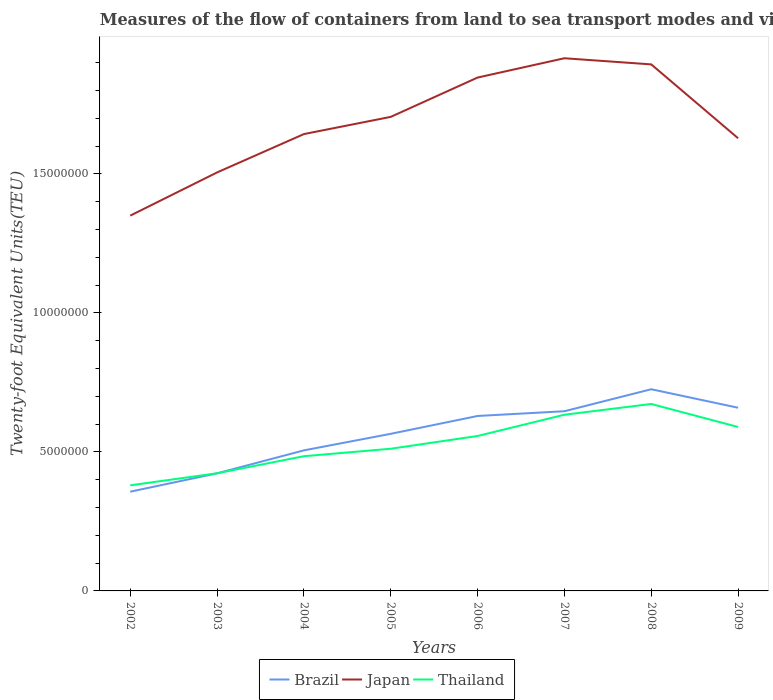How many different coloured lines are there?
Provide a succinct answer. 3. Across all years, what is the maximum container port traffic in Japan?
Make the answer very short. 1.35e+07. In which year was the container port traffic in Japan maximum?
Give a very brief answer. 2002. What is the total container port traffic in Thailand in the graph?
Your response must be concise. -1.34e+06. What is the difference between the highest and the second highest container port traffic in Thailand?
Ensure brevity in your answer.  2.93e+06. What is the difference between the highest and the lowest container port traffic in Japan?
Provide a short and direct response. 4. Is the container port traffic in Japan strictly greater than the container port traffic in Brazil over the years?
Make the answer very short. No. Are the values on the major ticks of Y-axis written in scientific E-notation?
Offer a very short reply. No. Does the graph contain grids?
Your answer should be very brief. No. How are the legend labels stacked?
Offer a terse response. Horizontal. What is the title of the graph?
Your response must be concise. Measures of the flow of containers from land to sea transport modes and vice versa. What is the label or title of the X-axis?
Ensure brevity in your answer.  Years. What is the label or title of the Y-axis?
Keep it short and to the point. Twenty-foot Equivalent Units(TEU). What is the Twenty-foot Equivalent Units(TEU) of Brazil in 2002?
Give a very brief answer. 3.57e+06. What is the Twenty-foot Equivalent Units(TEU) of Japan in 2002?
Your answer should be very brief. 1.35e+07. What is the Twenty-foot Equivalent Units(TEU) in Thailand in 2002?
Keep it short and to the point. 3.80e+06. What is the Twenty-foot Equivalent Units(TEU) in Brazil in 2003?
Your response must be concise. 4.23e+06. What is the Twenty-foot Equivalent Units(TEU) of Japan in 2003?
Provide a succinct answer. 1.51e+07. What is the Twenty-foot Equivalent Units(TEU) of Thailand in 2003?
Your response must be concise. 4.23e+06. What is the Twenty-foot Equivalent Units(TEU) of Brazil in 2004?
Give a very brief answer. 5.06e+06. What is the Twenty-foot Equivalent Units(TEU) in Japan in 2004?
Your answer should be compact. 1.64e+07. What is the Twenty-foot Equivalent Units(TEU) in Thailand in 2004?
Make the answer very short. 4.85e+06. What is the Twenty-foot Equivalent Units(TEU) of Brazil in 2005?
Provide a succinct answer. 5.65e+06. What is the Twenty-foot Equivalent Units(TEU) of Japan in 2005?
Make the answer very short. 1.71e+07. What is the Twenty-foot Equivalent Units(TEU) in Thailand in 2005?
Keep it short and to the point. 5.12e+06. What is the Twenty-foot Equivalent Units(TEU) in Brazil in 2006?
Your answer should be very brief. 6.29e+06. What is the Twenty-foot Equivalent Units(TEU) of Japan in 2006?
Your answer should be compact. 1.85e+07. What is the Twenty-foot Equivalent Units(TEU) in Thailand in 2006?
Your answer should be compact. 5.57e+06. What is the Twenty-foot Equivalent Units(TEU) of Brazil in 2007?
Your answer should be very brief. 6.46e+06. What is the Twenty-foot Equivalent Units(TEU) in Japan in 2007?
Offer a very short reply. 1.92e+07. What is the Twenty-foot Equivalent Units(TEU) in Thailand in 2007?
Provide a succinct answer. 6.34e+06. What is the Twenty-foot Equivalent Units(TEU) of Brazil in 2008?
Offer a terse response. 7.26e+06. What is the Twenty-foot Equivalent Units(TEU) of Japan in 2008?
Provide a short and direct response. 1.89e+07. What is the Twenty-foot Equivalent Units(TEU) of Thailand in 2008?
Your answer should be very brief. 6.73e+06. What is the Twenty-foot Equivalent Units(TEU) of Brazil in 2009?
Keep it short and to the point. 6.59e+06. What is the Twenty-foot Equivalent Units(TEU) of Japan in 2009?
Give a very brief answer. 1.63e+07. What is the Twenty-foot Equivalent Units(TEU) of Thailand in 2009?
Ensure brevity in your answer.  5.90e+06. Across all years, what is the maximum Twenty-foot Equivalent Units(TEU) in Brazil?
Your response must be concise. 7.26e+06. Across all years, what is the maximum Twenty-foot Equivalent Units(TEU) of Japan?
Provide a succinct answer. 1.92e+07. Across all years, what is the maximum Twenty-foot Equivalent Units(TEU) of Thailand?
Give a very brief answer. 6.73e+06. Across all years, what is the minimum Twenty-foot Equivalent Units(TEU) in Brazil?
Your answer should be very brief. 3.57e+06. Across all years, what is the minimum Twenty-foot Equivalent Units(TEU) of Japan?
Make the answer very short. 1.35e+07. Across all years, what is the minimum Twenty-foot Equivalent Units(TEU) in Thailand?
Your answer should be very brief. 3.80e+06. What is the total Twenty-foot Equivalent Units(TEU) in Brazil in the graph?
Provide a short and direct response. 4.51e+07. What is the total Twenty-foot Equivalent Units(TEU) of Japan in the graph?
Keep it short and to the point. 1.35e+08. What is the total Twenty-foot Equivalent Units(TEU) in Thailand in the graph?
Ensure brevity in your answer.  4.25e+07. What is the difference between the Twenty-foot Equivalent Units(TEU) in Brazil in 2002 and that in 2003?
Provide a short and direct response. -6.60e+05. What is the difference between the Twenty-foot Equivalent Units(TEU) of Japan in 2002 and that in 2003?
Your answer should be very brief. -1.55e+06. What is the difference between the Twenty-foot Equivalent Units(TEU) in Thailand in 2002 and that in 2003?
Offer a terse response. -4.34e+05. What is the difference between the Twenty-foot Equivalent Units(TEU) of Brazil in 2002 and that in 2004?
Provide a short and direct response. -1.49e+06. What is the difference between the Twenty-foot Equivalent Units(TEU) of Japan in 2002 and that in 2004?
Your response must be concise. -2.93e+06. What is the difference between the Twenty-foot Equivalent Units(TEU) of Thailand in 2002 and that in 2004?
Keep it short and to the point. -1.05e+06. What is the difference between the Twenty-foot Equivalent Units(TEU) in Brazil in 2002 and that in 2005?
Ensure brevity in your answer.  -2.08e+06. What is the difference between the Twenty-foot Equivalent Units(TEU) of Japan in 2002 and that in 2005?
Provide a succinct answer. -3.55e+06. What is the difference between the Twenty-foot Equivalent Units(TEU) of Thailand in 2002 and that in 2005?
Give a very brief answer. -1.32e+06. What is the difference between the Twenty-foot Equivalent Units(TEU) in Brazil in 2002 and that in 2006?
Your answer should be very brief. -2.72e+06. What is the difference between the Twenty-foot Equivalent Units(TEU) in Japan in 2002 and that in 2006?
Your answer should be compact. -4.97e+06. What is the difference between the Twenty-foot Equivalent Units(TEU) in Thailand in 2002 and that in 2006?
Make the answer very short. -1.78e+06. What is the difference between the Twenty-foot Equivalent Units(TEU) of Brazil in 2002 and that in 2007?
Make the answer very short. -2.89e+06. What is the difference between the Twenty-foot Equivalent Units(TEU) in Japan in 2002 and that in 2007?
Your answer should be very brief. -5.66e+06. What is the difference between the Twenty-foot Equivalent Units(TEU) in Thailand in 2002 and that in 2007?
Your answer should be very brief. -2.54e+06. What is the difference between the Twenty-foot Equivalent Units(TEU) in Brazil in 2002 and that in 2008?
Offer a terse response. -3.69e+06. What is the difference between the Twenty-foot Equivalent Units(TEU) of Japan in 2002 and that in 2008?
Your response must be concise. -5.44e+06. What is the difference between the Twenty-foot Equivalent Units(TEU) in Thailand in 2002 and that in 2008?
Offer a terse response. -2.93e+06. What is the difference between the Twenty-foot Equivalent Units(TEU) in Brazil in 2002 and that in 2009?
Provide a short and direct response. -3.02e+06. What is the difference between the Twenty-foot Equivalent Units(TEU) in Japan in 2002 and that in 2009?
Provide a succinct answer. -2.78e+06. What is the difference between the Twenty-foot Equivalent Units(TEU) of Thailand in 2002 and that in 2009?
Provide a succinct answer. -2.10e+06. What is the difference between the Twenty-foot Equivalent Units(TEU) of Brazil in 2003 and that in 2004?
Your answer should be very brief. -8.26e+05. What is the difference between the Twenty-foot Equivalent Units(TEU) of Japan in 2003 and that in 2004?
Make the answer very short. -1.38e+06. What is the difference between the Twenty-foot Equivalent Units(TEU) in Thailand in 2003 and that in 2004?
Your answer should be compact. -6.14e+05. What is the difference between the Twenty-foot Equivalent Units(TEU) in Brazil in 2003 and that in 2005?
Provide a short and direct response. -1.42e+06. What is the difference between the Twenty-foot Equivalent Units(TEU) in Japan in 2003 and that in 2005?
Offer a very short reply. -2.00e+06. What is the difference between the Twenty-foot Equivalent Units(TEU) in Thailand in 2003 and that in 2005?
Provide a short and direct response. -8.83e+05. What is the difference between the Twenty-foot Equivalent Units(TEU) in Brazil in 2003 and that in 2006?
Your response must be concise. -2.06e+06. What is the difference between the Twenty-foot Equivalent Units(TEU) in Japan in 2003 and that in 2006?
Provide a succinct answer. -3.41e+06. What is the difference between the Twenty-foot Equivalent Units(TEU) of Thailand in 2003 and that in 2006?
Ensure brevity in your answer.  -1.34e+06. What is the difference between the Twenty-foot Equivalent Units(TEU) of Brazil in 2003 and that in 2007?
Your response must be concise. -2.23e+06. What is the difference between the Twenty-foot Equivalent Units(TEU) in Japan in 2003 and that in 2007?
Keep it short and to the point. -4.11e+06. What is the difference between the Twenty-foot Equivalent Units(TEU) of Thailand in 2003 and that in 2007?
Ensure brevity in your answer.  -2.11e+06. What is the difference between the Twenty-foot Equivalent Units(TEU) of Brazil in 2003 and that in 2008?
Offer a terse response. -3.03e+06. What is the difference between the Twenty-foot Equivalent Units(TEU) in Japan in 2003 and that in 2008?
Your response must be concise. -3.89e+06. What is the difference between the Twenty-foot Equivalent Units(TEU) in Thailand in 2003 and that in 2008?
Ensure brevity in your answer.  -2.49e+06. What is the difference between the Twenty-foot Equivalent Units(TEU) in Brazil in 2003 and that in 2009?
Provide a succinct answer. -2.36e+06. What is the difference between the Twenty-foot Equivalent Units(TEU) in Japan in 2003 and that in 2009?
Your answer should be compact. -1.23e+06. What is the difference between the Twenty-foot Equivalent Units(TEU) in Thailand in 2003 and that in 2009?
Provide a short and direct response. -1.67e+06. What is the difference between the Twenty-foot Equivalent Units(TEU) in Brazil in 2004 and that in 2005?
Give a very brief answer. -5.95e+05. What is the difference between the Twenty-foot Equivalent Units(TEU) of Japan in 2004 and that in 2005?
Keep it short and to the point. -6.19e+05. What is the difference between the Twenty-foot Equivalent Units(TEU) in Thailand in 2004 and that in 2005?
Your response must be concise. -2.68e+05. What is the difference between the Twenty-foot Equivalent Units(TEU) in Brazil in 2004 and that in 2006?
Provide a succinct answer. -1.24e+06. What is the difference between the Twenty-foot Equivalent Units(TEU) of Japan in 2004 and that in 2006?
Ensure brevity in your answer.  -2.03e+06. What is the difference between the Twenty-foot Equivalent Units(TEU) in Thailand in 2004 and that in 2006?
Offer a very short reply. -7.27e+05. What is the difference between the Twenty-foot Equivalent Units(TEU) in Brazil in 2004 and that in 2007?
Your answer should be very brief. -1.41e+06. What is the difference between the Twenty-foot Equivalent Units(TEU) of Japan in 2004 and that in 2007?
Your answer should be compact. -2.73e+06. What is the difference between the Twenty-foot Equivalent Units(TEU) in Thailand in 2004 and that in 2007?
Offer a terse response. -1.49e+06. What is the difference between the Twenty-foot Equivalent Units(TEU) in Brazil in 2004 and that in 2008?
Your response must be concise. -2.20e+06. What is the difference between the Twenty-foot Equivalent Units(TEU) of Japan in 2004 and that in 2008?
Your response must be concise. -2.51e+06. What is the difference between the Twenty-foot Equivalent Units(TEU) of Thailand in 2004 and that in 2008?
Offer a very short reply. -1.88e+06. What is the difference between the Twenty-foot Equivalent Units(TEU) of Brazil in 2004 and that in 2009?
Provide a succinct answer. -1.53e+06. What is the difference between the Twenty-foot Equivalent Units(TEU) in Japan in 2004 and that in 2009?
Make the answer very short. 1.50e+05. What is the difference between the Twenty-foot Equivalent Units(TEU) of Thailand in 2004 and that in 2009?
Provide a short and direct response. -1.05e+06. What is the difference between the Twenty-foot Equivalent Units(TEU) of Brazil in 2005 and that in 2006?
Your answer should be compact. -6.42e+05. What is the difference between the Twenty-foot Equivalent Units(TEU) in Japan in 2005 and that in 2006?
Offer a terse response. -1.41e+06. What is the difference between the Twenty-foot Equivalent Units(TEU) in Thailand in 2005 and that in 2006?
Provide a short and direct response. -4.59e+05. What is the difference between the Twenty-foot Equivalent Units(TEU) in Brazil in 2005 and that in 2007?
Offer a terse response. -8.13e+05. What is the difference between the Twenty-foot Equivalent Units(TEU) of Japan in 2005 and that in 2007?
Make the answer very short. -2.11e+06. What is the difference between the Twenty-foot Equivalent Units(TEU) of Thailand in 2005 and that in 2007?
Provide a short and direct response. -1.22e+06. What is the difference between the Twenty-foot Equivalent Units(TEU) in Brazil in 2005 and that in 2008?
Ensure brevity in your answer.  -1.60e+06. What is the difference between the Twenty-foot Equivalent Units(TEU) of Japan in 2005 and that in 2008?
Keep it short and to the point. -1.89e+06. What is the difference between the Twenty-foot Equivalent Units(TEU) of Thailand in 2005 and that in 2008?
Give a very brief answer. -1.61e+06. What is the difference between the Twenty-foot Equivalent Units(TEU) in Brazil in 2005 and that in 2009?
Provide a succinct answer. -9.38e+05. What is the difference between the Twenty-foot Equivalent Units(TEU) of Japan in 2005 and that in 2009?
Give a very brief answer. 7.69e+05. What is the difference between the Twenty-foot Equivalent Units(TEU) of Thailand in 2005 and that in 2009?
Your response must be concise. -7.83e+05. What is the difference between the Twenty-foot Equivalent Units(TEU) in Brazil in 2006 and that in 2007?
Your answer should be very brief. -1.70e+05. What is the difference between the Twenty-foot Equivalent Units(TEU) of Japan in 2006 and that in 2007?
Your response must be concise. -6.95e+05. What is the difference between the Twenty-foot Equivalent Units(TEU) in Thailand in 2006 and that in 2007?
Offer a very short reply. -7.65e+05. What is the difference between the Twenty-foot Equivalent Units(TEU) of Brazil in 2006 and that in 2008?
Provide a short and direct response. -9.62e+05. What is the difference between the Twenty-foot Equivalent Units(TEU) in Japan in 2006 and that in 2008?
Your answer should be compact. -4.74e+05. What is the difference between the Twenty-foot Equivalent Units(TEU) in Thailand in 2006 and that in 2008?
Make the answer very short. -1.15e+06. What is the difference between the Twenty-foot Equivalent Units(TEU) of Brazil in 2006 and that in 2009?
Keep it short and to the point. -2.96e+05. What is the difference between the Twenty-foot Equivalent Units(TEU) in Japan in 2006 and that in 2009?
Your response must be concise. 2.18e+06. What is the difference between the Twenty-foot Equivalent Units(TEU) in Thailand in 2006 and that in 2009?
Your response must be concise. -3.23e+05. What is the difference between the Twenty-foot Equivalent Units(TEU) of Brazil in 2007 and that in 2008?
Your answer should be compact. -7.92e+05. What is the difference between the Twenty-foot Equivalent Units(TEU) in Japan in 2007 and that in 2008?
Make the answer very short. 2.21e+05. What is the difference between the Twenty-foot Equivalent Units(TEU) in Thailand in 2007 and that in 2008?
Give a very brief answer. -3.87e+05. What is the difference between the Twenty-foot Equivalent Units(TEU) in Brazil in 2007 and that in 2009?
Give a very brief answer. -1.26e+05. What is the difference between the Twenty-foot Equivalent Units(TEU) of Japan in 2007 and that in 2009?
Offer a terse response. 2.88e+06. What is the difference between the Twenty-foot Equivalent Units(TEU) in Thailand in 2007 and that in 2009?
Provide a succinct answer. 4.41e+05. What is the difference between the Twenty-foot Equivalent Units(TEU) of Brazil in 2008 and that in 2009?
Offer a terse response. 6.66e+05. What is the difference between the Twenty-foot Equivalent Units(TEU) of Japan in 2008 and that in 2009?
Keep it short and to the point. 2.66e+06. What is the difference between the Twenty-foot Equivalent Units(TEU) of Thailand in 2008 and that in 2009?
Your response must be concise. 8.28e+05. What is the difference between the Twenty-foot Equivalent Units(TEU) of Brazil in 2002 and the Twenty-foot Equivalent Units(TEU) of Japan in 2003?
Offer a very short reply. -1.15e+07. What is the difference between the Twenty-foot Equivalent Units(TEU) of Brazil in 2002 and the Twenty-foot Equivalent Units(TEU) of Thailand in 2003?
Provide a short and direct response. -6.62e+05. What is the difference between the Twenty-foot Equivalent Units(TEU) in Japan in 2002 and the Twenty-foot Equivalent Units(TEU) in Thailand in 2003?
Provide a short and direct response. 9.27e+06. What is the difference between the Twenty-foot Equivalent Units(TEU) of Brazil in 2002 and the Twenty-foot Equivalent Units(TEU) of Japan in 2004?
Ensure brevity in your answer.  -1.29e+07. What is the difference between the Twenty-foot Equivalent Units(TEU) of Brazil in 2002 and the Twenty-foot Equivalent Units(TEU) of Thailand in 2004?
Provide a succinct answer. -1.28e+06. What is the difference between the Twenty-foot Equivalent Units(TEU) of Japan in 2002 and the Twenty-foot Equivalent Units(TEU) of Thailand in 2004?
Make the answer very short. 8.65e+06. What is the difference between the Twenty-foot Equivalent Units(TEU) of Brazil in 2002 and the Twenty-foot Equivalent Units(TEU) of Japan in 2005?
Give a very brief answer. -1.35e+07. What is the difference between the Twenty-foot Equivalent Units(TEU) of Brazil in 2002 and the Twenty-foot Equivalent Units(TEU) of Thailand in 2005?
Provide a short and direct response. -1.54e+06. What is the difference between the Twenty-foot Equivalent Units(TEU) in Japan in 2002 and the Twenty-foot Equivalent Units(TEU) in Thailand in 2005?
Offer a very short reply. 8.39e+06. What is the difference between the Twenty-foot Equivalent Units(TEU) of Brazil in 2002 and the Twenty-foot Equivalent Units(TEU) of Japan in 2006?
Offer a terse response. -1.49e+07. What is the difference between the Twenty-foot Equivalent Units(TEU) of Brazil in 2002 and the Twenty-foot Equivalent Units(TEU) of Thailand in 2006?
Make the answer very short. -2.00e+06. What is the difference between the Twenty-foot Equivalent Units(TEU) in Japan in 2002 and the Twenty-foot Equivalent Units(TEU) in Thailand in 2006?
Offer a terse response. 7.93e+06. What is the difference between the Twenty-foot Equivalent Units(TEU) of Brazil in 2002 and the Twenty-foot Equivalent Units(TEU) of Japan in 2007?
Offer a terse response. -1.56e+07. What is the difference between the Twenty-foot Equivalent Units(TEU) in Brazil in 2002 and the Twenty-foot Equivalent Units(TEU) in Thailand in 2007?
Your answer should be compact. -2.77e+06. What is the difference between the Twenty-foot Equivalent Units(TEU) of Japan in 2002 and the Twenty-foot Equivalent Units(TEU) of Thailand in 2007?
Your response must be concise. 7.16e+06. What is the difference between the Twenty-foot Equivalent Units(TEU) of Brazil in 2002 and the Twenty-foot Equivalent Units(TEU) of Japan in 2008?
Offer a terse response. -1.54e+07. What is the difference between the Twenty-foot Equivalent Units(TEU) of Brazil in 2002 and the Twenty-foot Equivalent Units(TEU) of Thailand in 2008?
Your answer should be very brief. -3.16e+06. What is the difference between the Twenty-foot Equivalent Units(TEU) of Japan in 2002 and the Twenty-foot Equivalent Units(TEU) of Thailand in 2008?
Your response must be concise. 6.78e+06. What is the difference between the Twenty-foot Equivalent Units(TEU) in Brazil in 2002 and the Twenty-foot Equivalent Units(TEU) in Japan in 2009?
Give a very brief answer. -1.27e+07. What is the difference between the Twenty-foot Equivalent Units(TEU) of Brazil in 2002 and the Twenty-foot Equivalent Units(TEU) of Thailand in 2009?
Give a very brief answer. -2.33e+06. What is the difference between the Twenty-foot Equivalent Units(TEU) in Japan in 2002 and the Twenty-foot Equivalent Units(TEU) in Thailand in 2009?
Give a very brief answer. 7.60e+06. What is the difference between the Twenty-foot Equivalent Units(TEU) of Brazil in 2003 and the Twenty-foot Equivalent Units(TEU) of Japan in 2004?
Give a very brief answer. -1.22e+07. What is the difference between the Twenty-foot Equivalent Units(TEU) of Brazil in 2003 and the Twenty-foot Equivalent Units(TEU) of Thailand in 2004?
Offer a terse response. -6.17e+05. What is the difference between the Twenty-foot Equivalent Units(TEU) of Japan in 2003 and the Twenty-foot Equivalent Units(TEU) of Thailand in 2004?
Your answer should be compact. 1.02e+07. What is the difference between the Twenty-foot Equivalent Units(TEU) in Brazil in 2003 and the Twenty-foot Equivalent Units(TEU) in Japan in 2005?
Provide a short and direct response. -1.28e+07. What is the difference between the Twenty-foot Equivalent Units(TEU) in Brazil in 2003 and the Twenty-foot Equivalent Units(TEU) in Thailand in 2005?
Ensure brevity in your answer.  -8.85e+05. What is the difference between the Twenty-foot Equivalent Units(TEU) in Japan in 2003 and the Twenty-foot Equivalent Units(TEU) in Thailand in 2005?
Make the answer very short. 9.94e+06. What is the difference between the Twenty-foot Equivalent Units(TEU) in Brazil in 2003 and the Twenty-foot Equivalent Units(TEU) in Japan in 2006?
Provide a succinct answer. -1.42e+07. What is the difference between the Twenty-foot Equivalent Units(TEU) in Brazil in 2003 and the Twenty-foot Equivalent Units(TEU) in Thailand in 2006?
Ensure brevity in your answer.  -1.34e+06. What is the difference between the Twenty-foot Equivalent Units(TEU) in Japan in 2003 and the Twenty-foot Equivalent Units(TEU) in Thailand in 2006?
Ensure brevity in your answer.  9.48e+06. What is the difference between the Twenty-foot Equivalent Units(TEU) of Brazil in 2003 and the Twenty-foot Equivalent Units(TEU) of Japan in 2007?
Your answer should be compact. -1.49e+07. What is the difference between the Twenty-foot Equivalent Units(TEU) in Brazil in 2003 and the Twenty-foot Equivalent Units(TEU) in Thailand in 2007?
Keep it short and to the point. -2.11e+06. What is the difference between the Twenty-foot Equivalent Units(TEU) of Japan in 2003 and the Twenty-foot Equivalent Units(TEU) of Thailand in 2007?
Your response must be concise. 8.72e+06. What is the difference between the Twenty-foot Equivalent Units(TEU) in Brazil in 2003 and the Twenty-foot Equivalent Units(TEU) in Japan in 2008?
Your answer should be compact. -1.47e+07. What is the difference between the Twenty-foot Equivalent Units(TEU) of Brazil in 2003 and the Twenty-foot Equivalent Units(TEU) of Thailand in 2008?
Keep it short and to the point. -2.50e+06. What is the difference between the Twenty-foot Equivalent Units(TEU) of Japan in 2003 and the Twenty-foot Equivalent Units(TEU) of Thailand in 2008?
Keep it short and to the point. 8.33e+06. What is the difference between the Twenty-foot Equivalent Units(TEU) in Brazil in 2003 and the Twenty-foot Equivalent Units(TEU) in Japan in 2009?
Offer a terse response. -1.21e+07. What is the difference between the Twenty-foot Equivalent Units(TEU) in Brazil in 2003 and the Twenty-foot Equivalent Units(TEU) in Thailand in 2009?
Your answer should be compact. -1.67e+06. What is the difference between the Twenty-foot Equivalent Units(TEU) in Japan in 2003 and the Twenty-foot Equivalent Units(TEU) in Thailand in 2009?
Your answer should be compact. 9.16e+06. What is the difference between the Twenty-foot Equivalent Units(TEU) of Brazil in 2004 and the Twenty-foot Equivalent Units(TEU) of Japan in 2005?
Offer a terse response. -1.20e+07. What is the difference between the Twenty-foot Equivalent Units(TEU) in Brazil in 2004 and the Twenty-foot Equivalent Units(TEU) in Thailand in 2005?
Ensure brevity in your answer.  -5.84e+04. What is the difference between the Twenty-foot Equivalent Units(TEU) in Japan in 2004 and the Twenty-foot Equivalent Units(TEU) in Thailand in 2005?
Offer a terse response. 1.13e+07. What is the difference between the Twenty-foot Equivalent Units(TEU) in Brazil in 2004 and the Twenty-foot Equivalent Units(TEU) in Japan in 2006?
Provide a short and direct response. -1.34e+07. What is the difference between the Twenty-foot Equivalent Units(TEU) of Brazil in 2004 and the Twenty-foot Equivalent Units(TEU) of Thailand in 2006?
Your answer should be very brief. -5.18e+05. What is the difference between the Twenty-foot Equivalent Units(TEU) in Japan in 2004 and the Twenty-foot Equivalent Units(TEU) in Thailand in 2006?
Offer a terse response. 1.09e+07. What is the difference between the Twenty-foot Equivalent Units(TEU) of Brazil in 2004 and the Twenty-foot Equivalent Units(TEU) of Japan in 2007?
Ensure brevity in your answer.  -1.41e+07. What is the difference between the Twenty-foot Equivalent Units(TEU) of Brazil in 2004 and the Twenty-foot Equivalent Units(TEU) of Thailand in 2007?
Your answer should be compact. -1.28e+06. What is the difference between the Twenty-foot Equivalent Units(TEU) of Japan in 2004 and the Twenty-foot Equivalent Units(TEU) of Thailand in 2007?
Keep it short and to the point. 1.01e+07. What is the difference between the Twenty-foot Equivalent Units(TEU) in Brazil in 2004 and the Twenty-foot Equivalent Units(TEU) in Japan in 2008?
Give a very brief answer. -1.39e+07. What is the difference between the Twenty-foot Equivalent Units(TEU) of Brazil in 2004 and the Twenty-foot Equivalent Units(TEU) of Thailand in 2008?
Offer a terse response. -1.67e+06. What is the difference between the Twenty-foot Equivalent Units(TEU) of Japan in 2004 and the Twenty-foot Equivalent Units(TEU) of Thailand in 2008?
Your answer should be compact. 9.71e+06. What is the difference between the Twenty-foot Equivalent Units(TEU) of Brazil in 2004 and the Twenty-foot Equivalent Units(TEU) of Japan in 2009?
Offer a very short reply. -1.12e+07. What is the difference between the Twenty-foot Equivalent Units(TEU) of Brazil in 2004 and the Twenty-foot Equivalent Units(TEU) of Thailand in 2009?
Ensure brevity in your answer.  -8.41e+05. What is the difference between the Twenty-foot Equivalent Units(TEU) of Japan in 2004 and the Twenty-foot Equivalent Units(TEU) of Thailand in 2009?
Your answer should be compact. 1.05e+07. What is the difference between the Twenty-foot Equivalent Units(TEU) in Brazil in 2005 and the Twenty-foot Equivalent Units(TEU) in Japan in 2006?
Make the answer very short. -1.28e+07. What is the difference between the Twenty-foot Equivalent Units(TEU) in Brazil in 2005 and the Twenty-foot Equivalent Units(TEU) in Thailand in 2006?
Give a very brief answer. 7.77e+04. What is the difference between the Twenty-foot Equivalent Units(TEU) of Japan in 2005 and the Twenty-foot Equivalent Units(TEU) of Thailand in 2006?
Your answer should be very brief. 1.15e+07. What is the difference between the Twenty-foot Equivalent Units(TEU) in Brazil in 2005 and the Twenty-foot Equivalent Units(TEU) in Japan in 2007?
Ensure brevity in your answer.  -1.35e+07. What is the difference between the Twenty-foot Equivalent Units(TEU) in Brazil in 2005 and the Twenty-foot Equivalent Units(TEU) in Thailand in 2007?
Offer a terse response. -6.87e+05. What is the difference between the Twenty-foot Equivalent Units(TEU) of Japan in 2005 and the Twenty-foot Equivalent Units(TEU) of Thailand in 2007?
Give a very brief answer. 1.07e+07. What is the difference between the Twenty-foot Equivalent Units(TEU) of Brazil in 2005 and the Twenty-foot Equivalent Units(TEU) of Japan in 2008?
Your answer should be compact. -1.33e+07. What is the difference between the Twenty-foot Equivalent Units(TEU) in Brazil in 2005 and the Twenty-foot Equivalent Units(TEU) in Thailand in 2008?
Offer a very short reply. -1.07e+06. What is the difference between the Twenty-foot Equivalent Units(TEU) of Japan in 2005 and the Twenty-foot Equivalent Units(TEU) of Thailand in 2008?
Provide a succinct answer. 1.03e+07. What is the difference between the Twenty-foot Equivalent Units(TEU) of Brazil in 2005 and the Twenty-foot Equivalent Units(TEU) of Japan in 2009?
Keep it short and to the point. -1.06e+07. What is the difference between the Twenty-foot Equivalent Units(TEU) in Brazil in 2005 and the Twenty-foot Equivalent Units(TEU) in Thailand in 2009?
Keep it short and to the point. -2.46e+05. What is the difference between the Twenty-foot Equivalent Units(TEU) in Japan in 2005 and the Twenty-foot Equivalent Units(TEU) in Thailand in 2009?
Offer a very short reply. 1.12e+07. What is the difference between the Twenty-foot Equivalent Units(TEU) in Brazil in 2006 and the Twenty-foot Equivalent Units(TEU) in Japan in 2007?
Provide a succinct answer. -1.29e+07. What is the difference between the Twenty-foot Equivalent Units(TEU) of Brazil in 2006 and the Twenty-foot Equivalent Units(TEU) of Thailand in 2007?
Your response must be concise. -4.50e+04. What is the difference between the Twenty-foot Equivalent Units(TEU) in Japan in 2006 and the Twenty-foot Equivalent Units(TEU) in Thailand in 2007?
Offer a very short reply. 1.21e+07. What is the difference between the Twenty-foot Equivalent Units(TEU) of Brazil in 2006 and the Twenty-foot Equivalent Units(TEU) of Japan in 2008?
Offer a terse response. -1.26e+07. What is the difference between the Twenty-foot Equivalent Units(TEU) in Brazil in 2006 and the Twenty-foot Equivalent Units(TEU) in Thailand in 2008?
Provide a succinct answer. -4.32e+05. What is the difference between the Twenty-foot Equivalent Units(TEU) of Japan in 2006 and the Twenty-foot Equivalent Units(TEU) of Thailand in 2008?
Your answer should be compact. 1.17e+07. What is the difference between the Twenty-foot Equivalent Units(TEU) in Brazil in 2006 and the Twenty-foot Equivalent Units(TEU) in Japan in 2009?
Your answer should be very brief. -9.99e+06. What is the difference between the Twenty-foot Equivalent Units(TEU) of Brazil in 2006 and the Twenty-foot Equivalent Units(TEU) of Thailand in 2009?
Give a very brief answer. 3.96e+05. What is the difference between the Twenty-foot Equivalent Units(TEU) in Japan in 2006 and the Twenty-foot Equivalent Units(TEU) in Thailand in 2009?
Your response must be concise. 1.26e+07. What is the difference between the Twenty-foot Equivalent Units(TEU) in Brazil in 2007 and the Twenty-foot Equivalent Units(TEU) in Japan in 2008?
Provide a short and direct response. -1.25e+07. What is the difference between the Twenty-foot Equivalent Units(TEU) in Brazil in 2007 and the Twenty-foot Equivalent Units(TEU) in Thailand in 2008?
Your response must be concise. -2.62e+05. What is the difference between the Twenty-foot Equivalent Units(TEU) of Japan in 2007 and the Twenty-foot Equivalent Units(TEU) of Thailand in 2008?
Provide a succinct answer. 1.24e+07. What is the difference between the Twenty-foot Equivalent Units(TEU) in Brazil in 2007 and the Twenty-foot Equivalent Units(TEU) in Japan in 2009?
Offer a terse response. -9.82e+06. What is the difference between the Twenty-foot Equivalent Units(TEU) of Brazil in 2007 and the Twenty-foot Equivalent Units(TEU) of Thailand in 2009?
Offer a terse response. 5.67e+05. What is the difference between the Twenty-foot Equivalent Units(TEU) of Japan in 2007 and the Twenty-foot Equivalent Units(TEU) of Thailand in 2009?
Give a very brief answer. 1.33e+07. What is the difference between the Twenty-foot Equivalent Units(TEU) in Brazil in 2008 and the Twenty-foot Equivalent Units(TEU) in Japan in 2009?
Keep it short and to the point. -9.03e+06. What is the difference between the Twenty-foot Equivalent Units(TEU) of Brazil in 2008 and the Twenty-foot Equivalent Units(TEU) of Thailand in 2009?
Offer a very short reply. 1.36e+06. What is the difference between the Twenty-foot Equivalent Units(TEU) of Japan in 2008 and the Twenty-foot Equivalent Units(TEU) of Thailand in 2009?
Your answer should be very brief. 1.30e+07. What is the average Twenty-foot Equivalent Units(TEU) in Brazil per year?
Your response must be concise. 5.64e+06. What is the average Twenty-foot Equivalent Units(TEU) of Japan per year?
Your answer should be very brief. 1.69e+07. What is the average Twenty-foot Equivalent Units(TEU) in Thailand per year?
Offer a very short reply. 5.32e+06. In the year 2002, what is the difference between the Twenty-foot Equivalent Units(TEU) in Brazil and Twenty-foot Equivalent Units(TEU) in Japan?
Keep it short and to the point. -9.93e+06. In the year 2002, what is the difference between the Twenty-foot Equivalent Units(TEU) of Brazil and Twenty-foot Equivalent Units(TEU) of Thailand?
Your answer should be very brief. -2.29e+05. In the year 2002, what is the difference between the Twenty-foot Equivalent Units(TEU) of Japan and Twenty-foot Equivalent Units(TEU) of Thailand?
Give a very brief answer. 9.70e+06. In the year 2003, what is the difference between the Twenty-foot Equivalent Units(TEU) of Brazil and Twenty-foot Equivalent Units(TEU) of Japan?
Give a very brief answer. -1.08e+07. In the year 2003, what is the difference between the Twenty-foot Equivalent Units(TEU) in Brazil and Twenty-foot Equivalent Units(TEU) in Thailand?
Ensure brevity in your answer.  -2211. In the year 2003, what is the difference between the Twenty-foot Equivalent Units(TEU) in Japan and Twenty-foot Equivalent Units(TEU) in Thailand?
Give a very brief answer. 1.08e+07. In the year 2004, what is the difference between the Twenty-foot Equivalent Units(TEU) in Brazil and Twenty-foot Equivalent Units(TEU) in Japan?
Offer a very short reply. -1.14e+07. In the year 2004, what is the difference between the Twenty-foot Equivalent Units(TEU) in Brazil and Twenty-foot Equivalent Units(TEU) in Thailand?
Your answer should be very brief. 2.10e+05. In the year 2004, what is the difference between the Twenty-foot Equivalent Units(TEU) of Japan and Twenty-foot Equivalent Units(TEU) of Thailand?
Your answer should be very brief. 1.16e+07. In the year 2005, what is the difference between the Twenty-foot Equivalent Units(TEU) in Brazil and Twenty-foot Equivalent Units(TEU) in Japan?
Your answer should be compact. -1.14e+07. In the year 2005, what is the difference between the Twenty-foot Equivalent Units(TEU) of Brazil and Twenty-foot Equivalent Units(TEU) of Thailand?
Keep it short and to the point. 5.37e+05. In the year 2005, what is the difference between the Twenty-foot Equivalent Units(TEU) of Japan and Twenty-foot Equivalent Units(TEU) of Thailand?
Offer a very short reply. 1.19e+07. In the year 2006, what is the difference between the Twenty-foot Equivalent Units(TEU) of Brazil and Twenty-foot Equivalent Units(TEU) of Japan?
Offer a very short reply. -1.22e+07. In the year 2006, what is the difference between the Twenty-foot Equivalent Units(TEU) in Brazil and Twenty-foot Equivalent Units(TEU) in Thailand?
Keep it short and to the point. 7.20e+05. In the year 2006, what is the difference between the Twenty-foot Equivalent Units(TEU) of Japan and Twenty-foot Equivalent Units(TEU) of Thailand?
Offer a terse response. 1.29e+07. In the year 2007, what is the difference between the Twenty-foot Equivalent Units(TEU) in Brazil and Twenty-foot Equivalent Units(TEU) in Japan?
Ensure brevity in your answer.  -1.27e+07. In the year 2007, what is the difference between the Twenty-foot Equivalent Units(TEU) in Brazil and Twenty-foot Equivalent Units(TEU) in Thailand?
Offer a very short reply. 1.25e+05. In the year 2007, what is the difference between the Twenty-foot Equivalent Units(TEU) in Japan and Twenty-foot Equivalent Units(TEU) in Thailand?
Your answer should be compact. 1.28e+07. In the year 2008, what is the difference between the Twenty-foot Equivalent Units(TEU) of Brazil and Twenty-foot Equivalent Units(TEU) of Japan?
Offer a terse response. -1.17e+07. In the year 2008, what is the difference between the Twenty-foot Equivalent Units(TEU) in Brazil and Twenty-foot Equivalent Units(TEU) in Thailand?
Provide a short and direct response. 5.30e+05. In the year 2008, what is the difference between the Twenty-foot Equivalent Units(TEU) of Japan and Twenty-foot Equivalent Units(TEU) of Thailand?
Offer a terse response. 1.22e+07. In the year 2009, what is the difference between the Twenty-foot Equivalent Units(TEU) in Brazil and Twenty-foot Equivalent Units(TEU) in Japan?
Give a very brief answer. -9.70e+06. In the year 2009, what is the difference between the Twenty-foot Equivalent Units(TEU) in Brazil and Twenty-foot Equivalent Units(TEU) in Thailand?
Offer a very short reply. 6.92e+05. In the year 2009, what is the difference between the Twenty-foot Equivalent Units(TEU) of Japan and Twenty-foot Equivalent Units(TEU) of Thailand?
Your answer should be very brief. 1.04e+07. What is the ratio of the Twenty-foot Equivalent Units(TEU) of Brazil in 2002 to that in 2003?
Offer a very short reply. 0.84. What is the ratio of the Twenty-foot Equivalent Units(TEU) in Japan in 2002 to that in 2003?
Give a very brief answer. 0.9. What is the ratio of the Twenty-foot Equivalent Units(TEU) in Thailand in 2002 to that in 2003?
Your answer should be compact. 0.9. What is the ratio of the Twenty-foot Equivalent Units(TEU) of Brazil in 2002 to that in 2004?
Make the answer very short. 0.71. What is the ratio of the Twenty-foot Equivalent Units(TEU) of Japan in 2002 to that in 2004?
Your answer should be compact. 0.82. What is the ratio of the Twenty-foot Equivalent Units(TEU) in Thailand in 2002 to that in 2004?
Your answer should be very brief. 0.78. What is the ratio of the Twenty-foot Equivalent Units(TEU) in Brazil in 2002 to that in 2005?
Give a very brief answer. 0.63. What is the ratio of the Twenty-foot Equivalent Units(TEU) of Japan in 2002 to that in 2005?
Ensure brevity in your answer.  0.79. What is the ratio of the Twenty-foot Equivalent Units(TEU) in Thailand in 2002 to that in 2005?
Ensure brevity in your answer.  0.74. What is the ratio of the Twenty-foot Equivalent Units(TEU) in Brazil in 2002 to that in 2006?
Your response must be concise. 0.57. What is the ratio of the Twenty-foot Equivalent Units(TEU) of Japan in 2002 to that in 2006?
Your response must be concise. 0.73. What is the ratio of the Twenty-foot Equivalent Units(TEU) of Thailand in 2002 to that in 2006?
Offer a terse response. 0.68. What is the ratio of the Twenty-foot Equivalent Units(TEU) of Brazil in 2002 to that in 2007?
Offer a very short reply. 0.55. What is the ratio of the Twenty-foot Equivalent Units(TEU) of Japan in 2002 to that in 2007?
Offer a very short reply. 0.7. What is the ratio of the Twenty-foot Equivalent Units(TEU) in Thailand in 2002 to that in 2007?
Your answer should be very brief. 0.6. What is the ratio of the Twenty-foot Equivalent Units(TEU) in Brazil in 2002 to that in 2008?
Your answer should be very brief. 0.49. What is the ratio of the Twenty-foot Equivalent Units(TEU) in Japan in 2002 to that in 2008?
Give a very brief answer. 0.71. What is the ratio of the Twenty-foot Equivalent Units(TEU) of Thailand in 2002 to that in 2008?
Offer a very short reply. 0.56. What is the ratio of the Twenty-foot Equivalent Units(TEU) of Brazil in 2002 to that in 2009?
Provide a short and direct response. 0.54. What is the ratio of the Twenty-foot Equivalent Units(TEU) in Japan in 2002 to that in 2009?
Ensure brevity in your answer.  0.83. What is the ratio of the Twenty-foot Equivalent Units(TEU) of Thailand in 2002 to that in 2009?
Give a very brief answer. 0.64. What is the ratio of the Twenty-foot Equivalent Units(TEU) in Brazil in 2003 to that in 2004?
Give a very brief answer. 0.84. What is the ratio of the Twenty-foot Equivalent Units(TEU) of Japan in 2003 to that in 2004?
Provide a short and direct response. 0.92. What is the ratio of the Twenty-foot Equivalent Units(TEU) of Thailand in 2003 to that in 2004?
Ensure brevity in your answer.  0.87. What is the ratio of the Twenty-foot Equivalent Units(TEU) in Brazil in 2003 to that in 2005?
Make the answer very short. 0.75. What is the ratio of the Twenty-foot Equivalent Units(TEU) in Japan in 2003 to that in 2005?
Your answer should be very brief. 0.88. What is the ratio of the Twenty-foot Equivalent Units(TEU) in Thailand in 2003 to that in 2005?
Provide a succinct answer. 0.83. What is the ratio of the Twenty-foot Equivalent Units(TEU) in Brazil in 2003 to that in 2006?
Offer a terse response. 0.67. What is the ratio of the Twenty-foot Equivalent Units(TEU) in Japan in 2003 to that in 2006?
Make the answer very short. 0.82. What is the ratio of the Twenty-foot Equivalent Units(TEU) of Thailand in 2003 to that in 2006?
Offer a terse response. 0.76. What is the ratio of the Twenty-foot Equivalent Units(TEU) of Brazil in 2003 to that in 2007?
Keep it short and to the point. 0.65. What is the ratio of the Twenty-foot Equivalent Units(TEU) of Japan in 2003 to that in 2007?
Offer a terse response. 0.79. What is the ratio of the Twenty-foot Equivalent Units(TEU) in Thailand in 2003 to that in 2007?
Keep it short and to the point. 0.67. What is the ratio of the Twenty-foot Equivalent Units(TEU) of Brazil in 2003 to that in 2008?
Provide a short and direct response. 0.58. What is the ratio of the Twenty-foot Equivalent Units(TEU) in Japan in 2003 to that in 2008?
Provide a succinct answer. 0.79. What is the ratio of the Twenty-foot Equivalent Units(TEU) in Thailand in 2003 to that in 2008?
Your answer should be very brief. 0.63. What is the ratio of the Twenty-foot Equivalent Units(TEU) of Brazil in 2003 to that in 2009?
Give a very brief answer. 0.64. What is the ratio of the Twenty-foot Equivalent Units(TEU) in Japan in 2003 to that in 2009?
Your answer should be very brief. 0.92. What is the ratio of the Twenty-foot Equivalent Units(TEU) in Thailand in 2003 to that in 2009?
Ensure brevity in your answer.  0.72. What is the ratio of the Twenty-foot Equivalent Units(TEU) in Brazil in 2004 to that in 2005?
Provide a succinct answer. 0.89. What is the ratio of the Twenty-foot Equivalent Units(TEU) of Japan in 2004 to that in 2005?
Offer a very short reply. 0.96. What is the ratio of the Twenty-foot Equivalent Units(TEU) of Thailand in 2004 to that in 2005?
Your answer should be compact. 0.95. What is the ratio of the Twenty-foot Equivalent Units(TEU) in Brazil in 2004 to that in 2006?
Ensure brevity in your answer.  0.8. What is the ratio of the Twenty-foot Equivalent Units(TEU) of Japan in 2004 to that in 2006?
Provide a succinct answer. 0.89. What is the ratio of the Twenty-foot Equivalent Units(TEU) of Thailand in 2004 to that in 2006?
Provide a succinct answer. 0.87. What is the ratio of the Twenty-foot Equivalent Units(TEU) of Brazil in 2004 to that in 2007?
Your answer should be very brief. 0.78. What is the ratio of the Twenty-foot Equivalent Units(TEU) of Japan in 2004 to that in 2007?
Offer a terse response. 0.86. What is the ratio of the Twenty-foot Equivalent Units(TEU) of Thailand in 2004 to that in 2007?
Your response must be concise. 0.76. What is the ratio of the Twenty-foot Equivalent Units(TEU) in Brazil in 2004 to that in 2008?
Your answer should be compact. 0.7. What is the ratio of the Twenty-foot Equivalent Units(TEU) of Japan in 2004 to that in 2008?
Your response must be concise. 0.87. What is the ratio of the Twenty-foot Equivalent Units(TEU) in Thailand in 2004 to that in 2008?
Offer a terse response. 0.72. What is the ratio of the Twenty-foot Equivalent Units(TEU) in Brazil in 2004 to that in 2009?
Your answer should be compact. 0.77. What is the ratio of the Twenty-foot Equivalent Units(TEU) of Japan in 2004 to that in 2009?
Your response must be concise. 1.01. What is the ratio of the Twenty-foot Equivalent Units(TEU) in Thailand in 2004 to that in 2009?
Give a very brief answer. 0.82. What is the ratio of the Twenty-foot Equivalent Units(TEU) of Brazil in 2005 to that in 2006?
Make the answer very short. 0.9. What is the ratio of the Twenty-foot Equivalent Units(TEU) of Japan in 2005 to that in 2006?
Your answer should be compact. 0.92. What is the ratio of the Twenty-foot Equivalent Units(TEU) in Thailand in 2005 to that in 2006?
Keep it short and to the point. 0.92. What is the ratio of the Twenty-foot Equivalent Units(TEU) of Brazil in 2005 to that in 2007?
Offer a very short reply. 0.87. What is the ratio of the Twenty-foot Equivalent Units(TEU) of Japan in 2005 to that in 2007?
Offer a very short reply. 0.89. What is the ratio of the Twenty-foot Equivalent Units(TEU) of Thailand in 2005 to that in 2007?
Keep it short and to the point. 0.81. What is the ratio of the Twenty-foot Equivalent Units(TEU) in Brazil in 2005 to that in 2008?
Your answer should be very brief. 0.78. What is the ratio of the Twenty-foot Equivalent Units(TEU) of Japan in 2005 to that in 2008?
Offer a very short reply. 0.9. What is the ratio of the Twenty-foot Equivalent Units(TEU) in Thailand in 2005 to that in 2008?
Provide a short and direct response. 0.76. What is the ratio of the Twenty-foot Equivalent Units(TEU) of Brazil in 2005 to that in 2009?
Make the answer very short. 0.86. What is the ratio of the Twenty-foot Equivalent Units(TEU) of Japan in 2005 to that in 2009?
Your answer should be compact. 1.05. What is the ratio of the Twenty-foot Equivalent Units(TEU) of Thailand in 2005 to that in 2009?
Ensure brevity in your answer.  0.87. What is the ratio of the Twenty-foot Equivalent Units(TEU) of Brazil in 2006 to that in 2007?
Your response must be concise. 0.97. What is the ratio of the Twenty-foot Equivalent Units(TEU) in Japan in 2006 to that in 2007?
Ensure brevity in your answer.  0.96. What is the ratio of the Twenty-foot Equivalent Units(TEU) of Thailand in 2006 to that in 2007?
Provide a short and direct response. 0.88. What is the ratio of the Twenty-foot Equivalent Units(TEU) in Brazil in 2006 to that in 2008?
Your response must be concise. 0.87. What is the ratio of the Twenty-foot Equivalent Units(TEU) in Japan in 2006 to that in 2008?
Make the answer very short. 0.97. What is the ratio of the Twenty-foot Equivalent Units(TEU) in Thailand in 2006 to that in 2008?
Give a very brief answer. 0.83. What is the ratio of the Twenty-foot Equivalent Units(TEU) of Brazil in 2006 to that in 2009?
Your answer should be very brief. 0.96. What is the ratio of the Twenty-foot Equivalent Units(TEU) of Japan in 2006 to that in 2009?
Your response must be concise. 1.13. What is the ratio of the Twenty-foot Equivalent Units(TEU) of Thailand in 2006 to that in 2009?
Offer a terse response. 0.95. What is the ratio of the Twenty-foot Equivalent Units(TEU) in Brazil in 2007 to that in 2008?
Your answer should be very brief. 0.89. What is the ratio of the Twenty-foot Equivalent Units(TEU) in Japan in 2007 to that in 2008?
Your answer should be very brief. 1.01. What is the ratio of the Twenty-foot Equivalent Units(TEU) of Thailand in 2007 to that in 2008?
Provide a succinct answer. 0.94. What is the ratio of the Twenty-foot Equivalent Units(TEU) in Brazil in 2007 to that in 2009?
Keep it short and to the point. 0.98. What is the ratio of the Twenty-foot Equivalent Units(TEU) in Japan in 2007 to that in 2009?
Your response must be concise. 1.18. What is the ratio of the Twenty-foot Equivalent Units(TEU) in Thailand in 2007 to that in 2009?
Provide a short and direct response. 1.07. What is the ratio of the Twenty-foot Equivalent Units(TEU) of Brazil in 2008 to that in 2009?
Give a very brief answer. 1.1. What is the ratio of the Twenty-foot Equivalent Units(TEU) of Japan in 2008 to that in 2009?
Provide a short and direct response. 1.16. What is the ratio of the Twenty-foot Equivalent Units(TEU) in Thailand in 2008 to that in 2009?
Give a very brief answer. 1.14. What is the difference between the highest and the second highest Twenty-foot Equivalent Units(TEU) in Brazil?
Ensure brevity in your answer.  6.66e+05. What is the difference between the highest and the second highest Twenty-foot Equivalent Units(TEU) of Japan?
Offer a terse response. 2.21e+05. What is the difference between the highest and the second highest Twenty-foot Equivalent Units(TEU) of Thailand?
Your response must be concise. 3.87e+05. What is the difference between the highest and the lowest Twenty-foot Equivalent Units(TEU) of Brazil?
Offer a very short reply. 3.69e+06. What is the difference between the highest and the lowest Twenty-foot Equivalent Units(TEU) of Japan?
Keep it short and to the point. 5.66e+06. What is the difference between the highest and the lowest Twenty-foot Equivalent Units(TEU) in Thailand?
Your response must be concise. 2.93e+06. 